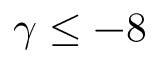<formula> <loc_0><loc_0><loc_500><loc_500>\gamma \leq - 8</formula> 